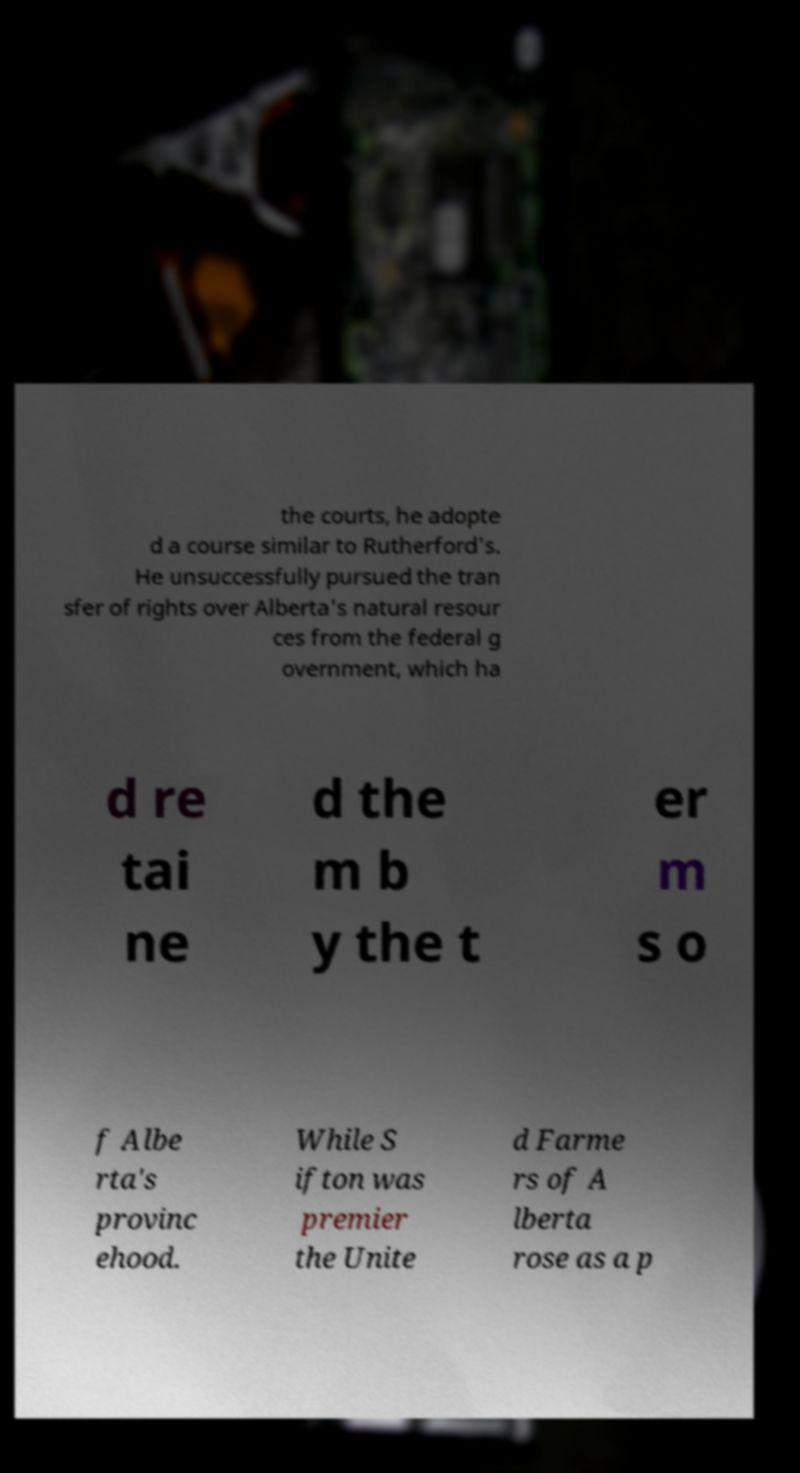Please read and relay the text visible in this image. What does it say? the courts, he adopte d a course similar to Rutherford's. He unsuccessfully pursued the tran sfer of rights over Alberta's natural resour ces from the federal g overnment, which ha d re tai ne d the m b y the t er m s o f Albe rta's provinc ehood. While S ifton was premier the Unite d Farme rs of A lberta rose as a p 